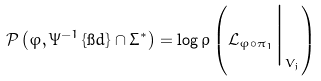Convert formula to latex. <formula><loc_0><loc_0><loc_500><loc_500>\mathcal { P } \left ( \varphi , \Psi ^ { - 1 } \left \{ \i d \right \} \cap \Sigma ^ { * } \right ) = \log \rho \left ( \mathcal { L } _ { \varphi \circ \pi _ { 1 } } \Big | _ { V _ { j } } \right )</formula> 